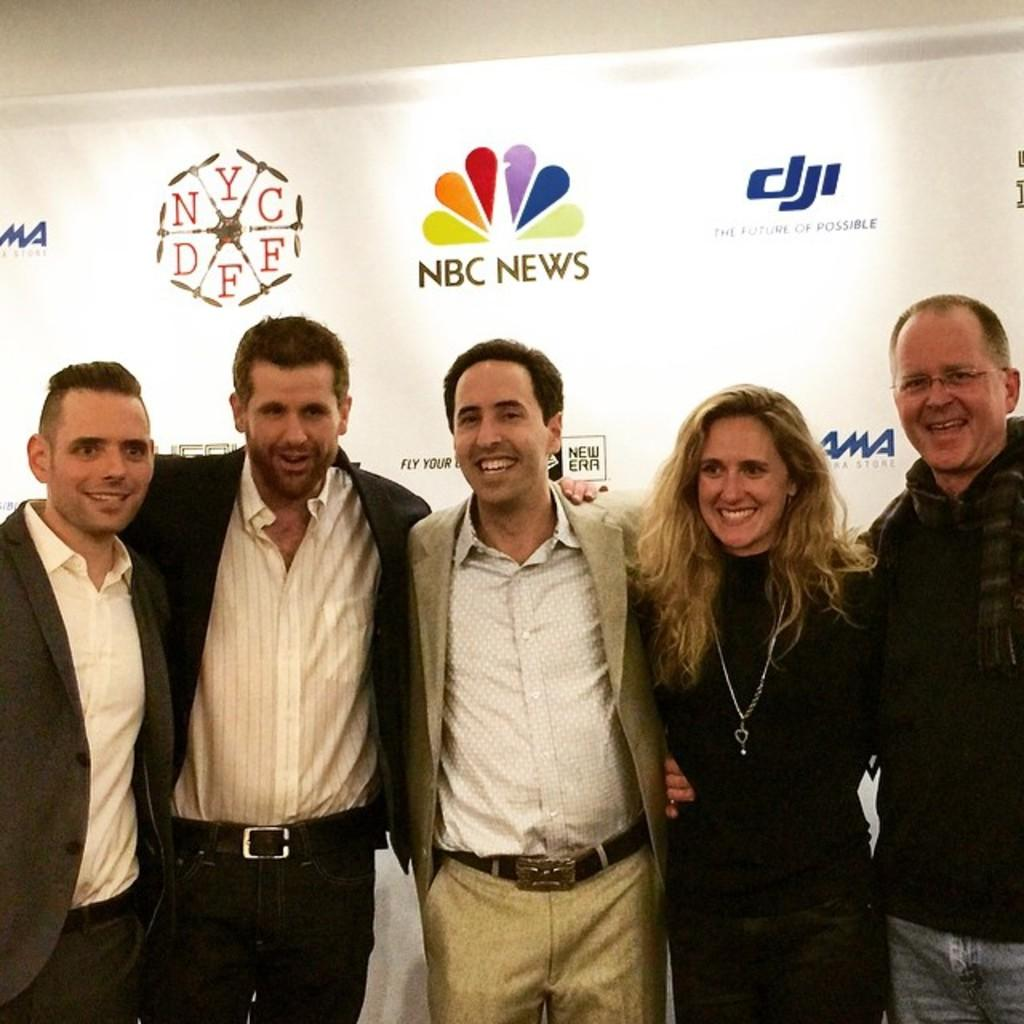How many people are present in the image? There are five persons in the image. What are the people doing in the image? The persons are standing. What can be seen in the background of the image? There are logos visible in the background of the image. What type of quince is being used as a prop in the image? There is no quince present in the image. How many letters are visible on the persons' clothing in the image? The provided facts do not mention any letters on the persons' clothing, so we cannot determine the number of letters visible. 